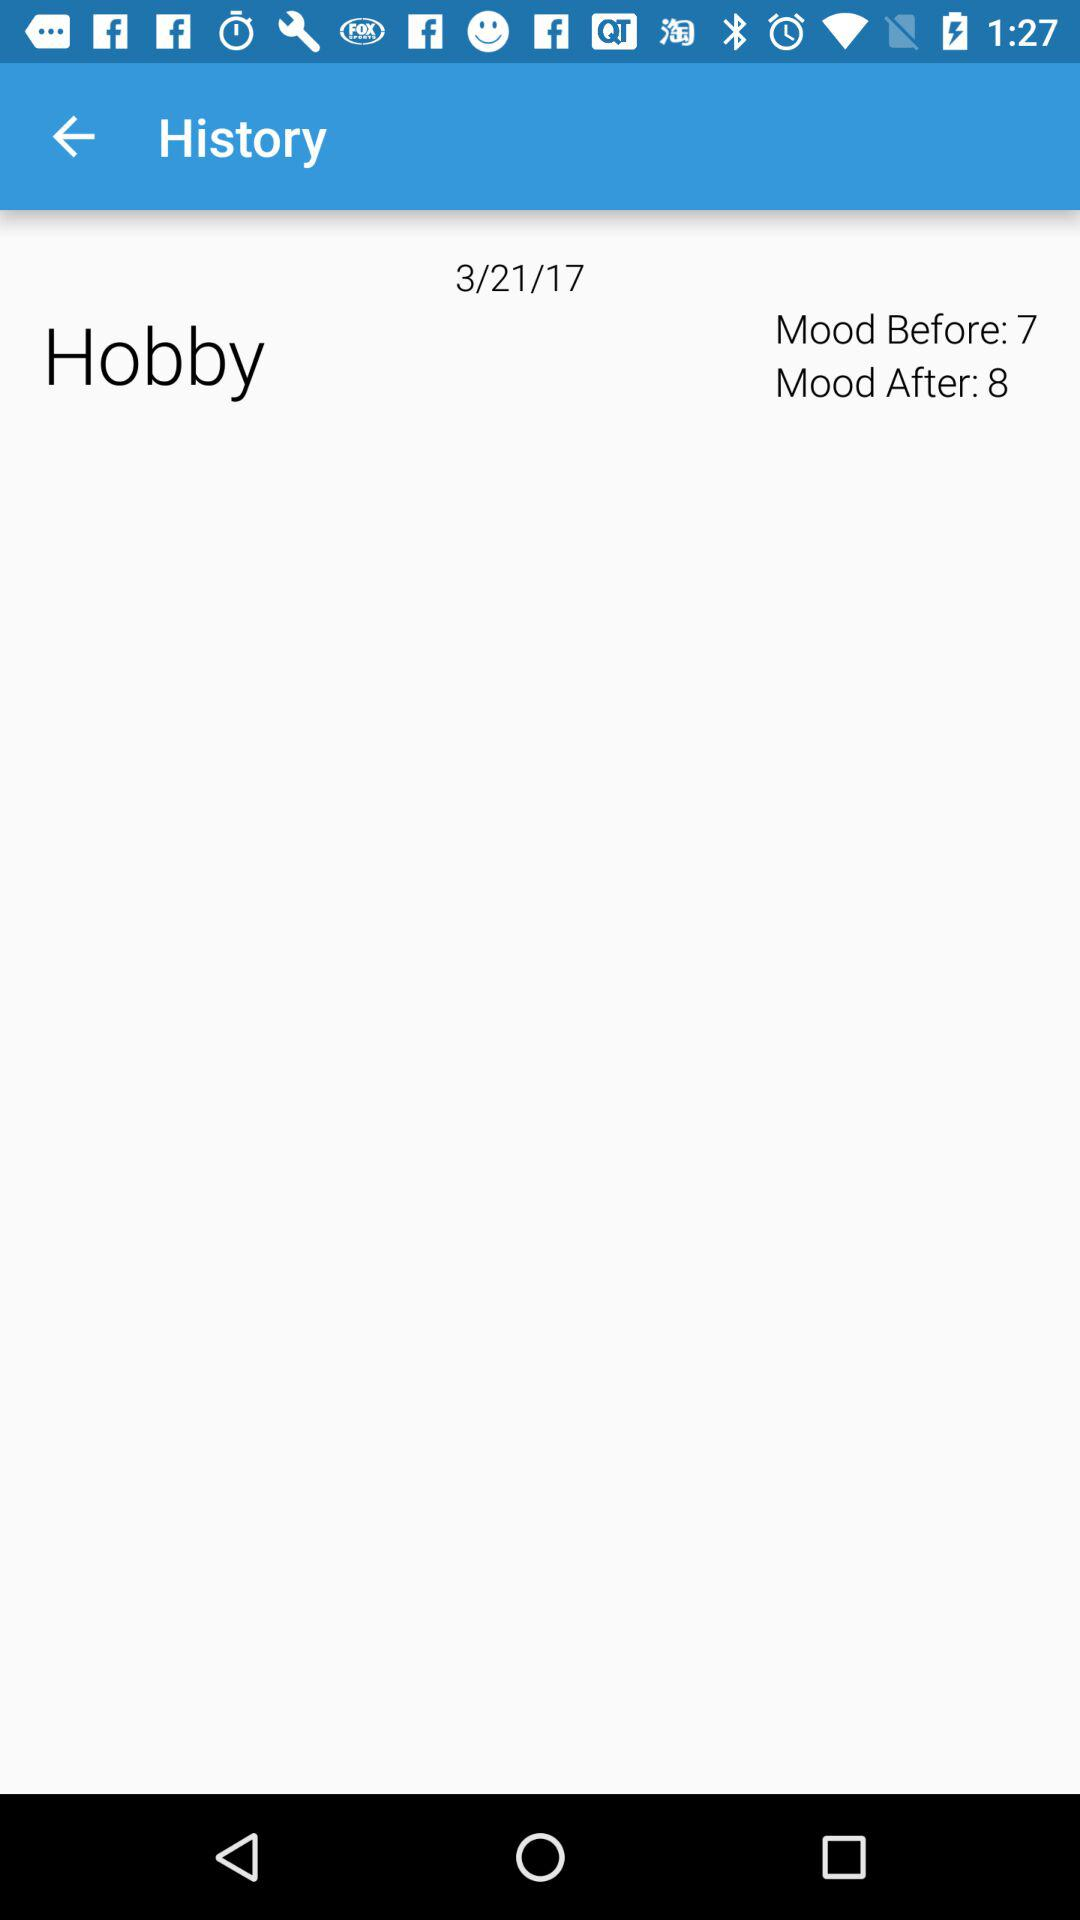What is the difference between the before and after mood?
Answer the question using a single word or phrase. 1 